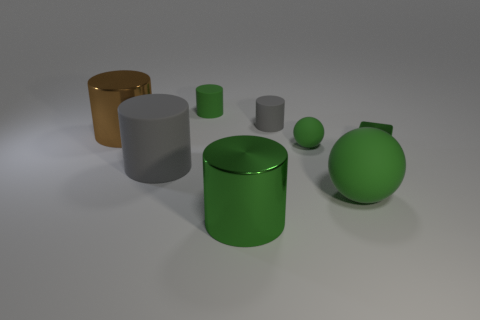There is another cylinder that is made of the same material as the large green cylinder; what color is it? The other cylinder that appears to be made of the same glossy material as the large green cylinder is grey. 